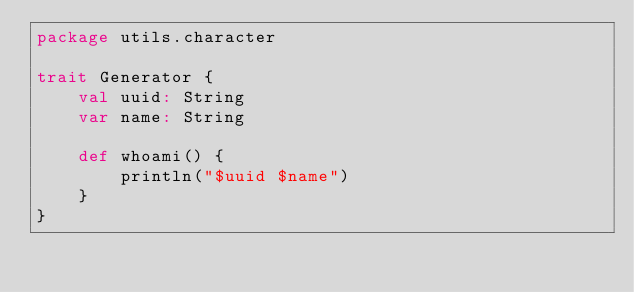Convert code to text. <code><loc_0><loc_0><loc_500><loc_500><_Scala_>package utils.character

trait Generator {
    val uuid: String
    var name: String

    def whoami() {
        println("$uuid $name")
    }
}</code> 